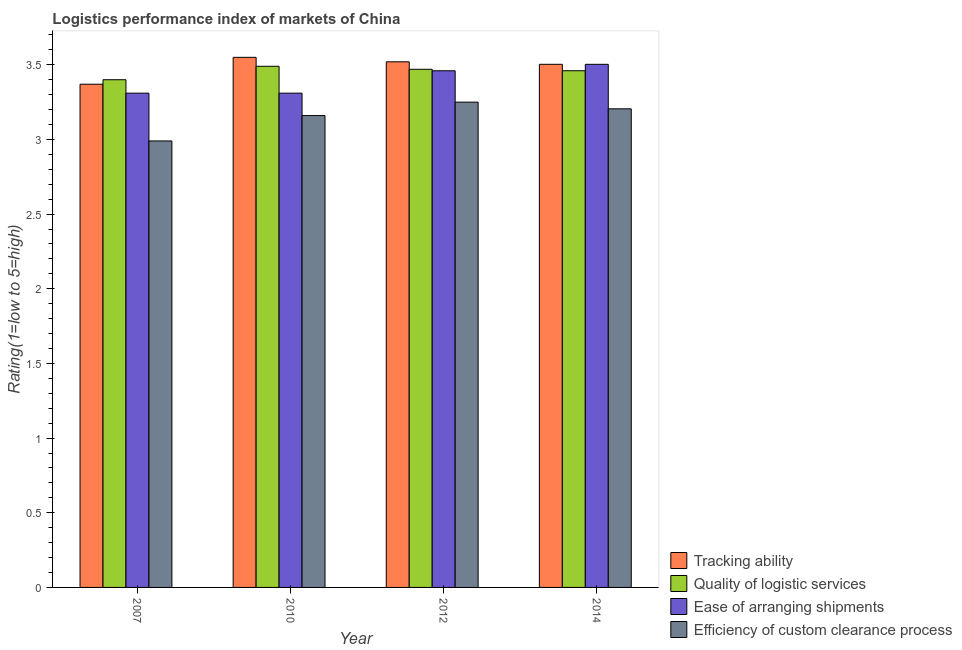How many different coloured bars are there?
Offer a very short reply. 4. How many bars are there on the 3rd tick from the left?
Your response must be concise. 4. In how many cases, is the number of bars for a given year not equal to the number of legend labels?
Keep it short and to the point. 0. What is the lpi rating of ease of arranging shipments in 2007?
Offer a very short reply. 3.31. Across all years, what is the maximum lpi rating of ease of arranging shipments?
Ensure brevity in your answer.  3.5. Across all years, what is the minimum lpi rating of efficiency of custom clearance process?
Keep it short and to the point. 2.99. What is the total lpi rating of ease of arranging shipments in the graph?
Provide a short and direct response. 13.58. What is the difference between the lpi rating of quality of logistic services in 2007 and that in 2012?
Offer a terse response. -0.07. What is the difference between the lpi rating of efficiency of custom clearance process in 2014 and the lpi rating of ease of arranging shipments in 2010?
Offer a terse response. 0.05. What is the average lpi rating of tracking ability per year?
Your answer should be very brief. 3.49. In how many years, is the lpi rating of efficiency of custom clearance process greater than 3.5?
Your answer should be very brief. 0. What is the ratio of the lpi rating of quality of logistic services in 2007 to that in 2010?
Offer a terse response. 0.97. Is the lpi rating of quality of logistic services in 2007 less than that in 2012?
Keep it short and to the point. Yes. What is the difference between the highest and the second highest lpi rating of efficiency of custom clearance process?
Provide a short and direct response. 0.04. What is the difference between the highest and the lowest lpi rating of tracking ability?
Offer a terse response. 0.18. In how many years, is the lpi rating of ease of arranging shipments greater than the average lpi rating of ease of arranging shipments taken over all years?
Ensure brevity in your answer.  2. What does the 4th bar from the left in 2014 represents?
Your response must be concise. Efficiency of custom clearance process. What does the 1st bar from the right in 2010 represents?
Make the answer very short. Efficiency of custom clearance process. How many bars are there?
Provide a short and direct response. 16. Are all the bars in the graph horizontal?
Keep it short and to the point. No. How many years are there in the graph?
Provide a succinct answer. 4. Are the values on the major ticks of Y-axis written in scientific E-notation?
Your answer should be compact. No. Does the graph contain any zero values?
Offer a very short reply. No. Where does the legend appear in the graph?
Make the answer very short. Bottom right. What is the title of the graph?
Keep it short and to the point. Logistics performance index of markets of China. Does "Bird species" appear as one of the legend labels in the graph?
Your answer should be compact. No. What is the label or title of the Y-axis?
Provide a short and direct response. Rating(1=low to 5=high). What is the Rating(1=low to 5=high) in Tracking ability in 2007?
Your answer should be compact. 3.37. What is the Rating(1=low to 5=high) of Ease of arranging shipments in 2007?
Your response must be concise. 3.31. What is the Rating(1=low to 5=high) in Efficiency of custom clearance process in 2007?
Provide a succinct answer. 2.99. What is the Rating(1=low to 5=high) in Tracking ability in 2010?
Provide a short and direct response. 3.55. What is the Rating(1=low to 5=high) in Quality of logistic services in 2010?
Offer a terse response. 3.49. What is the Rating(1=low to 5=high) of Ease of arranging shipments in 2010?
Your answer should be very brief. 3.31. What is the Rating(1=low to 5=high) of Efficiency of custom clearance process in 2010?
Your answer should be compact. 3.16. What is the Rating(1=low to 5=high) of Tracking ability in 2012?
Ensure brevity in your answer.  3.52. What is the Rating(1=low to 5=high) in Quality of logistic services in 2012?
Make the answer very short. 3.47. What is the Rating(1=low to 5=high) of Ease of arranging shipments in 2012?
Your answer should be compact. 3.46. What is the Rating(1=low to 5=high) in Tracking ability in 2014?
Offer a very short reply. 3.5. What is the Rating(1=low to 5=high) of Quality of logistic services in 2014?
Offer a very short reply. 3.46. What is the Rating(1=low to 5=high) in Ease of arranging shipments in 2014?
Give a very brief answer. 3.5. What is the Rating(1=low to 5=high) in Efficiency of custom clearance process in 2014?
Your answer should be compact. 3.21. Across all years, what is the maximum Rating(1=low to 5=high) in Tracking ability?
Your answer should be compact. 3.55. Across all years, what is the maximum Rating(1=low to 5=high) of Quality of logistic services?
Provide a succinct answer. 3.49. Across all years, what is the maximum Rating(1=low to 5=high) of Ease of arranging shipments?
Give a very brief answer. 3.5. Across all years, what is the maximum Rating(1=low to 5=high) in Efficiency of custom clearance process?
Your answer should be very brief. 3.25. Across all years, what is the minimum Rating(1=low to 5=high) in Tracking ability?
Give a very brief answer. 3.37. Across all years, what is the minimum Rating(1=low to 5=high) of Quality of logistic services?
Give a very brief answer. 3.4. Across all years, what is the minimum Rating(1=low to 5=high) of Ease of arranging shipments?
Provide a short and direct response. 3.31. Across all years, what is the minimum Rating(1=low to 5=high) of Efficiency of custom clearance process?
Make the answer very short. 2.99. What is the total Rating(1=low to 5=high) in Tracking ability in the graph?
Your response must be concise. 13.94. What is the total Rating(1=low to 5=high) in Quality of logistic services in the graph?
Make the answer very short. 13.82. What is the total Rating(1=low to 5=high) of Ease of arranging shipments in the graph?
Your response must be concise. 13.58. What is the total Rating(1=low to 5=high) in Efficiency of custom clearance process in the graph?
Offer a very short reply. 12.61. What is the difference between the Rating(1=low to 5=high) in Tracking ability in 2007 and that in 2010?
Your response must be concise. -0.18. What is the difference between the Rating(1=low to 5=high) in Quality of logistic services in 2007 and that in 2010?
Make the answer very short. -0.09. What is the difference between the Rating(1=low to 5=high) in Efficiency of custom clearance process in 2007 and that in 2010?
Your response must be concise. -0.17. What is the difference between the Rating(1=low to 5=high) of Quality of logistic services in 2007 and that in 2012?
Keep it short and to the point. -0.07. What is the difference between the Rating(1=low to 5=high) in Ease of arranging shipments in 2007 and that in 2012?
Your response must be concise. -0.15. What is the difference between the Rating(1=low to 5=high) of Efficiency of custom clearance process in 2007 and that in 2012?
Your answer should be very brief. -0.26. What is the difference between the Rating(1=low to 5=high) of Tracking ability in 2007 and that in 2014?
Give a very brief answer. -0.13. What is the difference between the Rating(1=low to 5=high) in Quality of logistic services in 2007 and that in 2014?
Give a very brief answer. -0.06. What is the difference between the Rating(1=low to 5=high) of Ease of arranging shipments in 2007 and that in 2014?
Make the answer very short. -0.19. What is the difference between the Rating(1=low to 5=high) in Efficiency of custom clearance process in 2007 and that in 2014?
Offer a very short reply. -0.22. What is the difference between the Rating(1=low to 5=high) in Efficiency of custom clearance process in 2010 and that in 2012?
Give a very brief answer. -0.09. What is the difference between the Rating(1=low to 5=high) in Tracking ability in 2010 and that in 2014?
Keep it short and to the point. 0.05. What is the difference between the Rating(1=low to 5=high) of Quality of logistic services in 2010 and that in 2014?
Offer a very short reply. 0.03. What is the difference between the Rating(1=low to 5=high) of Ease of arranging shipments in 2010 and that in 2014?
Offer a very short reply. -0.19. What is the difference between the Rating(1=low to 5=high) in Efficiency of custom clearance process in 2010 and that in 2014?
Keep it short and to the point. -0.05. What is the difference between the Rating(1=low to 5=high) in Tracking ability in 2012 and that in 2014?
Keep it short and to the point. 0.02. What is the difference between the Rating(1=low to 5=high) of Quality of logistic services in 2012 and that in 2014?
Your response must be concise. 0.01. What is the difference between the Rating(1=low to 5=high) of Ease of arranging shipments in 2012 and that in 2014?
Keep it short and to the point. -0.04. What is the difference between the Rating(1=low to 5=high) of Efficiency of custom clearance process in 2012 and that in 2014?
Your response must be concise. 0.04. What is the difference between the Rating(1=low to 5=high) of Tracking ability in 2007 and the Rating(1=low to 5=high) of Quality of logistic services in 2010?
Keep it short and to the point. -0.12. What is the difference between the Rating(1=low to 5=high) in Tracking ability in 2007 and the Rating(1=low to 5=high) in Efficiency of custom clearance process in 2010?
Keep it short and to the point. 0.21. What is the difference between the Rating(1=low to 5=high) in Quality of logistic services in 2007 and the Rating(1=low to 5=high) in Ease of arranging shipments in 2010?
Make the answer very short. 0.09. What is the difference between the Rating(1=low to 5=high) of Quality of logistic services in 2007 and the Rating(1=low to 5=high) of Efficiency of custom clearance process in 2010?
Your answer should be very brief. 0.24. What is the difference between the Rating(1=low to 5=high) in Ease of arranging shipments in 2007 and the Rating(1=low to 5=high) in Efficiency of custom clearance process in 2010?
Offer a terse response. 0.15. What is the difference between the Rating(1=low to 5=high) of Tracking ability in 2007 and the Rating(1=low to 5=high) of Quality of logistic services in 2012?
Ensure brevity in your answer.  -0.1. What is the difference between the Rating(1=low to 5=high) of Tracking ability in 2007 and the Rating(1=low to 5=high) of Ease of arranging shipments in 2012?
Keep it short and to the point. -0.09. What is the difference between the Rating(1=low to 5=high) of Tracking ability in 2007 and the Rating(1=low to 5=high) of Efficiency of custom clearance process in 2012?
Your response must be concise. 0.12. What is the difference between the Rating(1=low to 5=high) in Quality of logistic services in 2007 and the Rating(1=low to 5=high) in Ease of arranging shipments in 2012?
Make the answer very short. -0.06. What is the difference between the Rating(1=low to 5=high) in Tracking ability in 2007 and the Rating(1=low to 5=high) in Quality of logistic services in 2014?
Provide a succinct answer. -0.09. What is the difference between the Rating(1=low to 5=high) of Tracking ability in 2007 and the Rating(1=low to 5=high) of Ease of arranging shipments in 2014?
Ensure brevity in your answer.  -0.13. What is the difference between the Rating(1=low to 5=high) in Tracking ability in 2007 and the Rating(1=low to 5=high) in Efficiency of custom clearance process in 2014?
Give a very brief answer. 0.16. What is the difference between the Rating(1=low to 5=high) in Quality of logistic services in 2007 and the Rating(1=low to 5=high) in Ease of arranging shipments in 2014?
Give a very brief answer. -0.1. What is the difference between the Rating(1=low to 5=high) of Quality of logistic services in 2007 and the Rating(1=low to 5=high) of Efficiency of custom clearance process in 2014?
Your response must be concise. 0.19. What is the difference between the Rating(1=low to 5=high) in Ease of arranging shipments in 2007 and the Rating(1=low to 5=high) in Efficiency of custom clearance process in 2014?
Ensure brevity in your answer.  0.1. What is the difference between the Rating(1=low to 5=high) of Tracking ability in 2010 and the Rating(1=low to 5=high) of Quality of logistic services in 2012?
Provide a short and direct response. 0.08. What is the difference between the Rating(1=low to 5=high) of Tracking ability in 2010 and the Rating(1=low to 5=high) of Ease of arranging shipments in 2012?
Offer a very short reply. 0.09. What is the difference between the Rating(1=low to 5=high) of Tracking ability in 2010 and the Rating(1=low to 5=high) of Efficiency of custom clearance process in 2012?
Your answer should be compact. 0.3. What is the difference between the Rating(1=low to 5=high) in Quality of logistic services in 2010 and the Rating(1=low to 5=high) in Efficiency of custom clearance process in 2012?
Provide a short and direct response. 0.24. What is the difference between the Rating(1=low to 5=high) of Tracking ability in 2010 and the Rating(1=low to 5=high) of Quality of logistic services in 2014?
Give a very brief answer. 0.09. What is the difference between the Rating(1=low to 5=high) of Tracking ability in 2010 and the Rating(1=low to 5=high) of Ease of arranging shipments in 2014?
Your answer should be very brief. 0.05. What is the difference between the Rating(1=low to 5=high) in Tracking ability in 2010 and the Rating(1=low to 5=high) in Efficiency of custom clearance process in 2014?
Ensure brevity in your answer.  0.34. What is the difference between the Rating(1=low to 5=high) in Quality of logistic services in 2010 and the Rating(1=low to 5=high) in Ease of arranging shipments in 2014?
Keep it short and to the point. -0.01. What is the difference between the Rating(1=low to 5=high) in Quality of logistic services in 2010 and the Rating(1=low to 5=high) in Efficiency of custom clearance process in 2014?
Offer a terse response. 0.28. What is the difference between the Rating(1=low to 5=high) in Ease of arranging shipments in 2010 and the Rating(1=low to 5=high) in Efficiency of custom clearance process in 2014?
Your answer should be compact. 0.1. What is the difference between the Rating(1=low to 5=high) in Tracking ability in 2012 and the Rating(1=low to 5=high) in Quality of logistic services in 2014?
Make the answer very short. 0.06. What is the difference between the Rating(1=low to 5=high) of Tracking ability in 2012 and the Rating(1=low to 5=high) of Ease of arranging shipments in 2014?
Your answer should be very brief. 0.02. What is the difference between the Rating(1=low to 5=high) of Tracking ability in 2012 and the Rating(1=low to 5=high) of Efficiency of custom clearance process in 2014?
Provide a succinct answer. 0.31. What is the difference between the Rating(1=low to 5=high) in Quality of logistic services in 2012 and the Rating(1=low to 5=high) in Ease of arranging shipments in 2014?
Ensure brevity in your answer.  -0.03. What is the difference between the Rating(1=low to 5=high) of Quality of logistic services in 2012 and the Rating(1=low to 5=high) of Efficiency of custom clearance process in 2014?
Provide a short and direct response. 0.26. What is the difference between the Rating(1=low to 5=high) in Ease of arranging shipments in 2012 and the Rating(1=low to 5=high) in Efficiency of custom clearance process in 2014?
Offer a very short reply. 0.25. What is the average Rating(1=low to 5=high) of Tracking ability per year?
Provide a succinct answer. 3.49. What is the average Rating(1=low to 5=high) in Quality of logistic services per year?
Offer a very short reply. 3.46. What is the average Rating(1=low to 5=high) in Ease of arranging shipments per year?
Make the answer very short. 3.4. What is the average Rating(1=low to 5=high) of Efficiency of custom clearance process per year?
Make the answer very short. 3.15. In the year 2007, what is the difference between the Rating(1=low to 5=high) of Tracking ability and Rating(1=low to 5=high) of Quality of logistic services?
Make the answer very short. -0.03. In the year 2007, what is the difference between the Rating(1=low to 5=high) in Tracking ability and Rating(1=low to 5=high) in Efficiency of custom clearance process?
Offer a very short reply. 0.38. In the year 2007, what is the difference between the Rating(1=low to 5=high) in Quality of logistic services and Rating(1=low to 5=high) in Ease of arranging shipments?
Make the answer very short. 0.09. In the year 2007, what is the difference between the Rating(1=low to 5=high) in Quality of logistic services and Rating(1=low to 5=high) in Efficiency of custom clearance process?
Make the answer very short. 0.41. In the year 2007, what is the difference between the Rating(1=low to 5=high) of Ease of arranging shipments and Rating(1=low to 5=high) of Efficiency of custom clearance process?
Offer a terse response. 0.32. In the year 2010, what is the difference between the Rating(1=low to 5=high) of Tracking ability and Rating(1=low to 5=high) of Ease of arranging shipments?
Ensure brevity in your answer.  0.24. In the year 2010, what is the difference between the Rating(1=low to 5=high) of Tracking ability and Rating(1=low to 5=high) of Efficiency of custom clearance process?
Your answer should be very brief. 0.39. In the year 2010, what is the difference between the Rating(1=low to 5=high) of Quality of logistic services and Rating(1=low to 5=high) of Ease of arranging shipments?
Provide a short and direct response. 0.18. In the year 2010, what is the difference between the Rating(1=low to 5=high) of Quality of logistic services and Rating(1=low to 5=high) of Efficiency of custom clearance process?
Offer a very short reply. 0.33. In the year 2010, what is the difference between the Rating(1=low to 5=high) of Ease of arranging shipments and Rating(1=low to 5=high) of Efficiency of custom clearance process?
Your answer should be compact. 0.15. In the year 2012, what is the difference between the Rating(1=low to 5=high) in Tracking ability and Rating(1=low to 5=high) in Ease of arranging shipments?
Ensure brevity in your answer.  0.06. In the year 2012, what is the difference between the Rating(1=low to 5=high) of Tracking ability and Rating(1=low to 5=high) of Efficiency of custom clearance process?
Your response must be concise. 0.27. In the year 2012, what is the difference between the Rating(1=low to 5=high) in Quality of logistic services and Rating(1=low to 5=high) in Efficiency of custom clearance process?
Your answer should be compact. 0.22. In the year 2012, what is the difference between the Rating(1=low to 5=high) in Ease of arranging shipments and Rating(1=low to 5=high) in Efficiency of custom clearance process?
Offer a terse response. 0.21. In the year 2014, what is the difference between the Rating(1=low to 5=high) of Tracking ability and Rating(1=low to 5=high) of Quality of logistic services?
Keep it short and to the point. 0.04. In the year 2014, what is the difference between the Rating(1=low to 5=high) in Tracking ability and Rating(1=low to 5=high) in Efficiency of custom clearance process?
Make the answer very short. 0.3. In the year 2014, what is the difference between the Rating(1=low to 5=high) of Quality of logistic services and Rating(1=low to 5=high) of Ease of arranging shipments?
Keep it short and to the point. -0.04. In the year 2014, what is the difference between the Rating(1=low to 5=high) in Quality of logistic services and Rating(1=low to 5=high) in Efficiency of custom clearance process?
Give a very brief answer. 0.26. In the year 2014, what is the difference between the Rating(1=low to 5=high) of Ease of arranging shipments and Rating(1=low to 5=high) of Efficiency of custom clearance process?
Give a very brief answer. 0.3. What is the ratio of the Rating(1=low to 5=high) of Tracking ability in 2007 to that in 2010?
Offer a very short reply. 0.95. What is the ratio of the Rating(1=low to 5=high) of Quality of logistic services in 2007 to that in 2010?
Make the answer very short. 0.97. What is the ratio of the Rating(1=low to 5=high) of Ease of arranging shipments in 2007 to that in 2010?
Keep it short and to the point. 1. What is the ratio of the Rating(1=low to 5=high) in Efficiency of custom clearance process in 2007 to that in 2010?
Ensure brevity in your answer.  0.95. What is the ratio of the Rating(1=low to 5=high) in Tracking ability in 2007 to that in 2012?
Your answer should be compact. 0.96. What is the ratio of the Rating(1=low to 5=high) of Quality of logistic services in 2007 to that in 2012?
Provide a short and direct response. 0.98. What is the ratio of the Rating(1=low to 5=high) of Ease of arranging shipments in 2007 to that in 2012?
Your answer should be very brief. 0.96. What is the ratio of the Rating(1=low to 5=high) in Quality of logistic services in 2007 to that in 2014?
Provide a succinct answer. 0.98. What is the ratio of the Rating(1=low to 5=high) of Ease of arranging shipments in 2007 to that in 2014?
Provide a short and direct response. 0.94. What is the ratio of the Rating(1=low to 5=high) of Efficiency of custom clearance process in 2007 to that in 2014?
Your answer should be compact. 0.93. What is the ratio of the Rating(1=low to 5=high) of Tracking ability in 2010 to that in 2012?
Your response must be concise. 1.01. What is the ratio of the Rating(1=low to 5=high) in Quality of logistic services in 2010 to that in 2012?
Offer a terse response. 1.01. What is the ratio of the Rating(1=low to 5=high) in Ease of arranging shipments in 2010 to that in 2012?
Your answer should be compact. 0.96. What is the ratio of the Rating(1=low to 5=high) of Efficiency of custom clearance process in 2010 to that in 2012?
Offer a very short reply. 0.97. What is the ratio of the Rating(1=low to 5=high) in Tracking ability in 2010 to that in 2014?
Ensure brevity in your answer.  1.01. What is the ratio of the Rating(1=low to 5=high) of Quality of logistic services in 2010 to that in 2014?
Offer a terse response. 1.01. What is the ratio of the Rating(1=low to 5=high) of Ease of arranging shipments in 2010 to that in 2014?
Provide a succinct answer. 0.94. What is the ratio of the Rating(1=low to 5=high) in Efficiency of custom clearance process in 2010 to that in 2014?
Keep it short and to the point. 0.99. What is the ratio of the Rating(1=low to 5=high) in Quality of logistic services in 2012 to that in 2014?
Keep it short and to the point. 1. What is the ratio of the Rating(1=low to 5=high) of Ease of arranging shipments in 2012 to that in 2014?
Offer a terse response. 0.99. What is the difference between the highest and the second highest Rating(1=low to 5=high) in Tracking ability?
Keep it short and to the point. 0.03. What is the difference between the highest and the second highest Rating(1=low to 5=high) of Ease of arranging shipments?
Keep it short and to the point. 0.04. What is the difference between the highest and the second highest Rating(1=low to 5=high) in Efficiency of custom clearance process?
Your response must be concise. 0.04. What is the difference between the highest and the lowest Rating(1=low to 5=high) of Tracking ability?
Make the answer very short. 0.18. What is the difference between the highest and the lowest Rating(1=low to 5=high) of Quality of logistic services?
Offer a terse response. 0.09. What is the difference between the highest and the lowest Rating(1=low to 5=high) in Ease of arranging shipments?
Provide a succinct answer. 0.19. What is the difference between the highest and the lowest Rating(1=low to 5=high) in Efficiency of custom clearance process?
Provide a succinct answer. 0.26. 